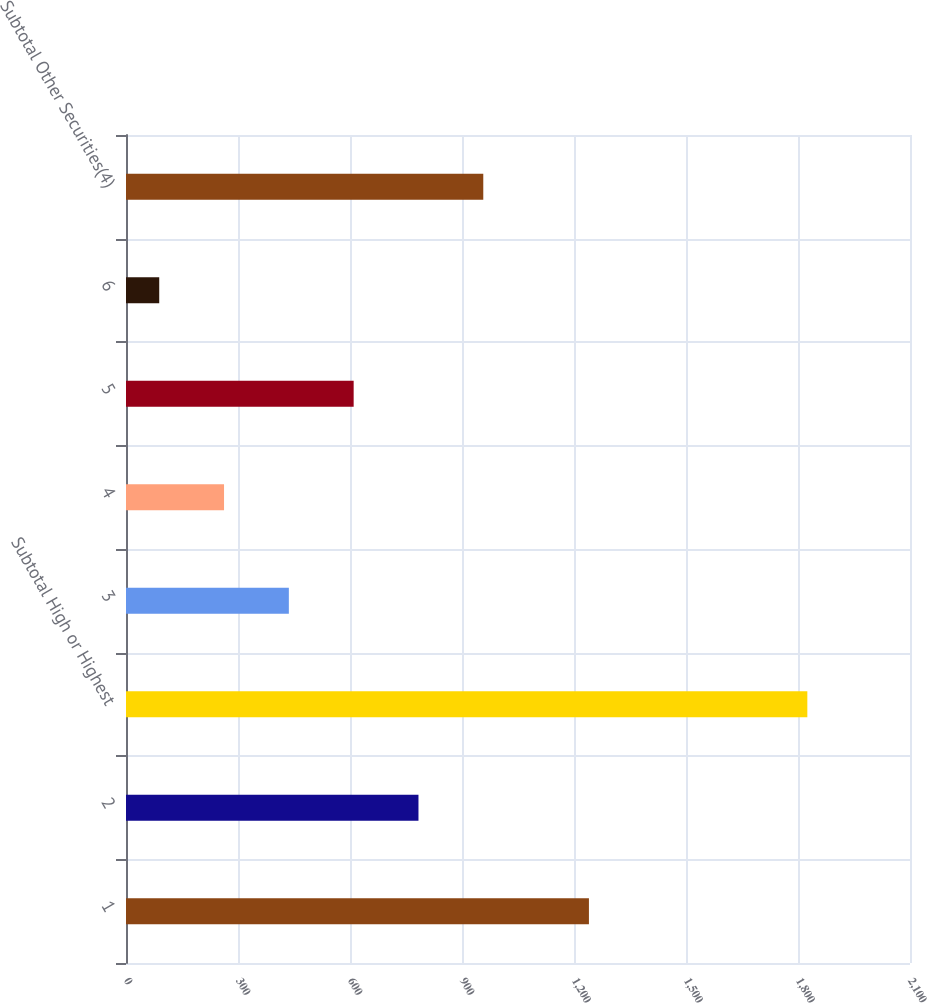Convert chart to OTSL. <chart><loc_0><loc_0><loc_500><loc_500><bar_chart><fcel>1<fcel>2<fcel>Subtotal High or Highest<fcel>3<fcel>4<fcel>5<fcel>6<fcel>Subtotal Other Securities(4)<nl><fcel>1240<fcel>783.4<fcel>1825<fcel>436.2<fcel>262.6<fcel>609.8<fcel>89<fcel>957<nl></chart> 